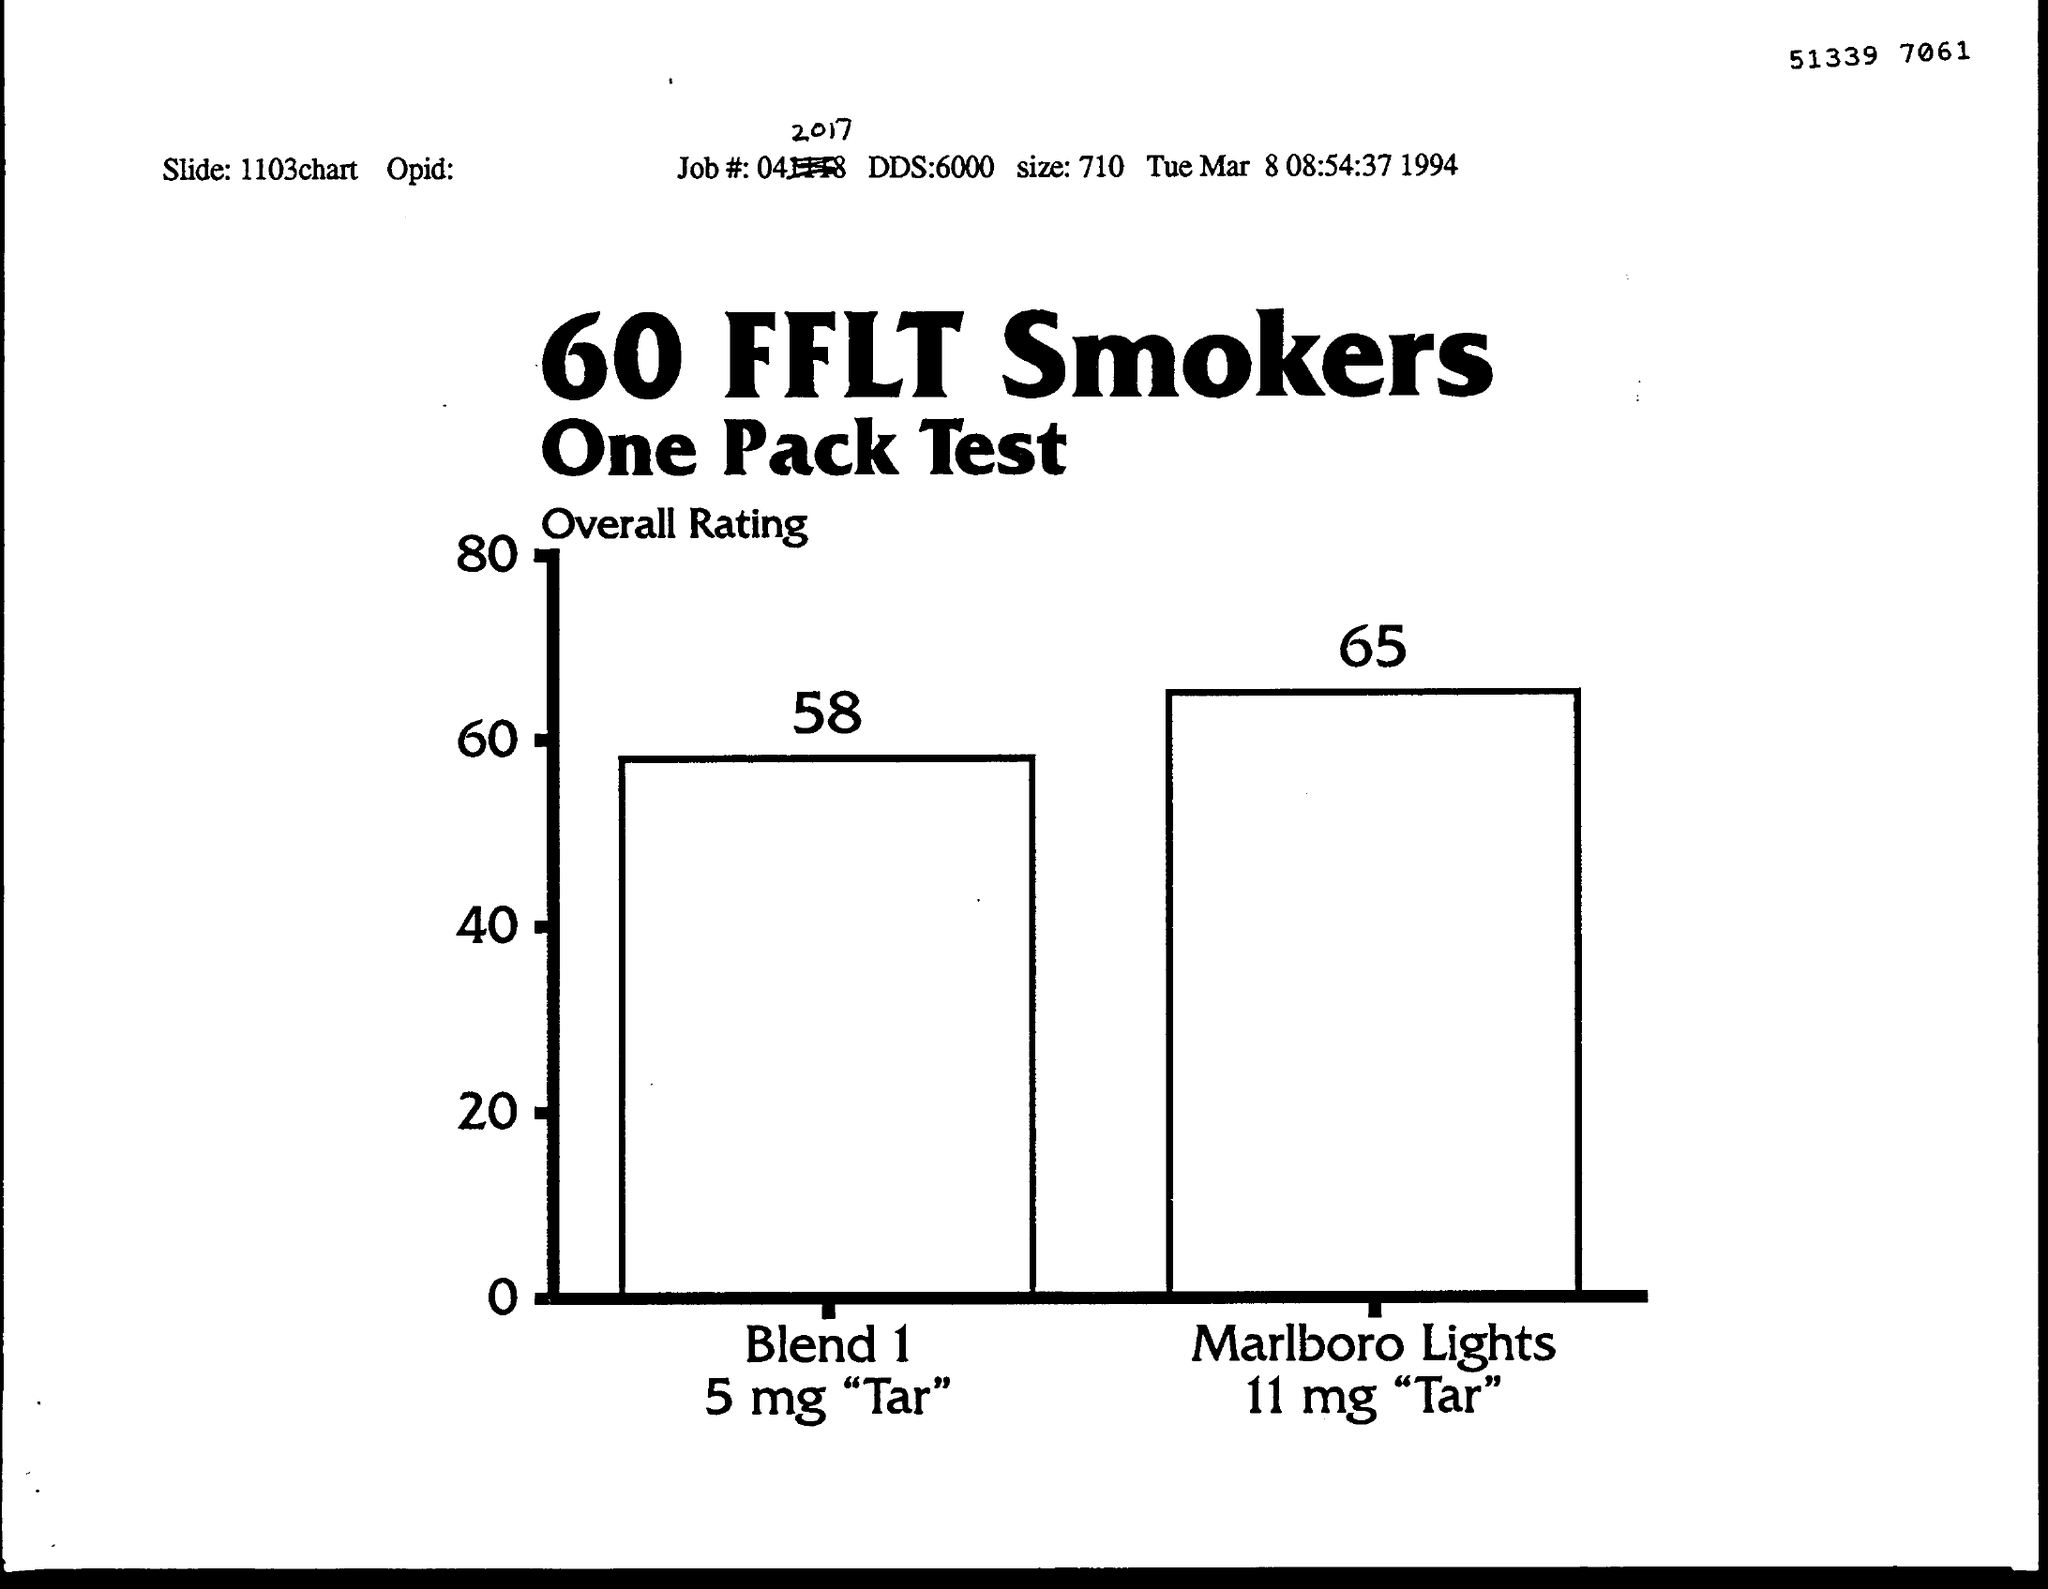Specify some key components in this picture. The size of 710..." is approximately 710 units in length. DDS refers to 6000... The job number is 042017. 